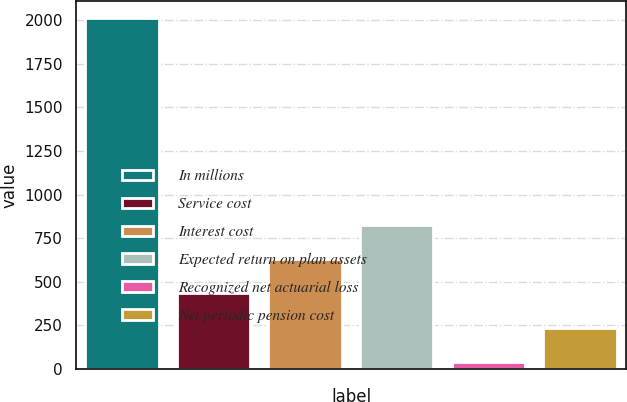Convert chart to OTSL. <chart><loc_0><loc_0><loc_500><loc_500><bar_chart><fcel>In millions<fcel>Service cost<fcel>Interest cost<fcel>Expected return on plan assets<fcel>Recognized net actuarial loss<fcel>Net periodic pension cost<nl><fcel>2011<fcel>433.4<fcel>630.6<fcel>827.8<fcel>39<fcel>236.2<nl></chart> 